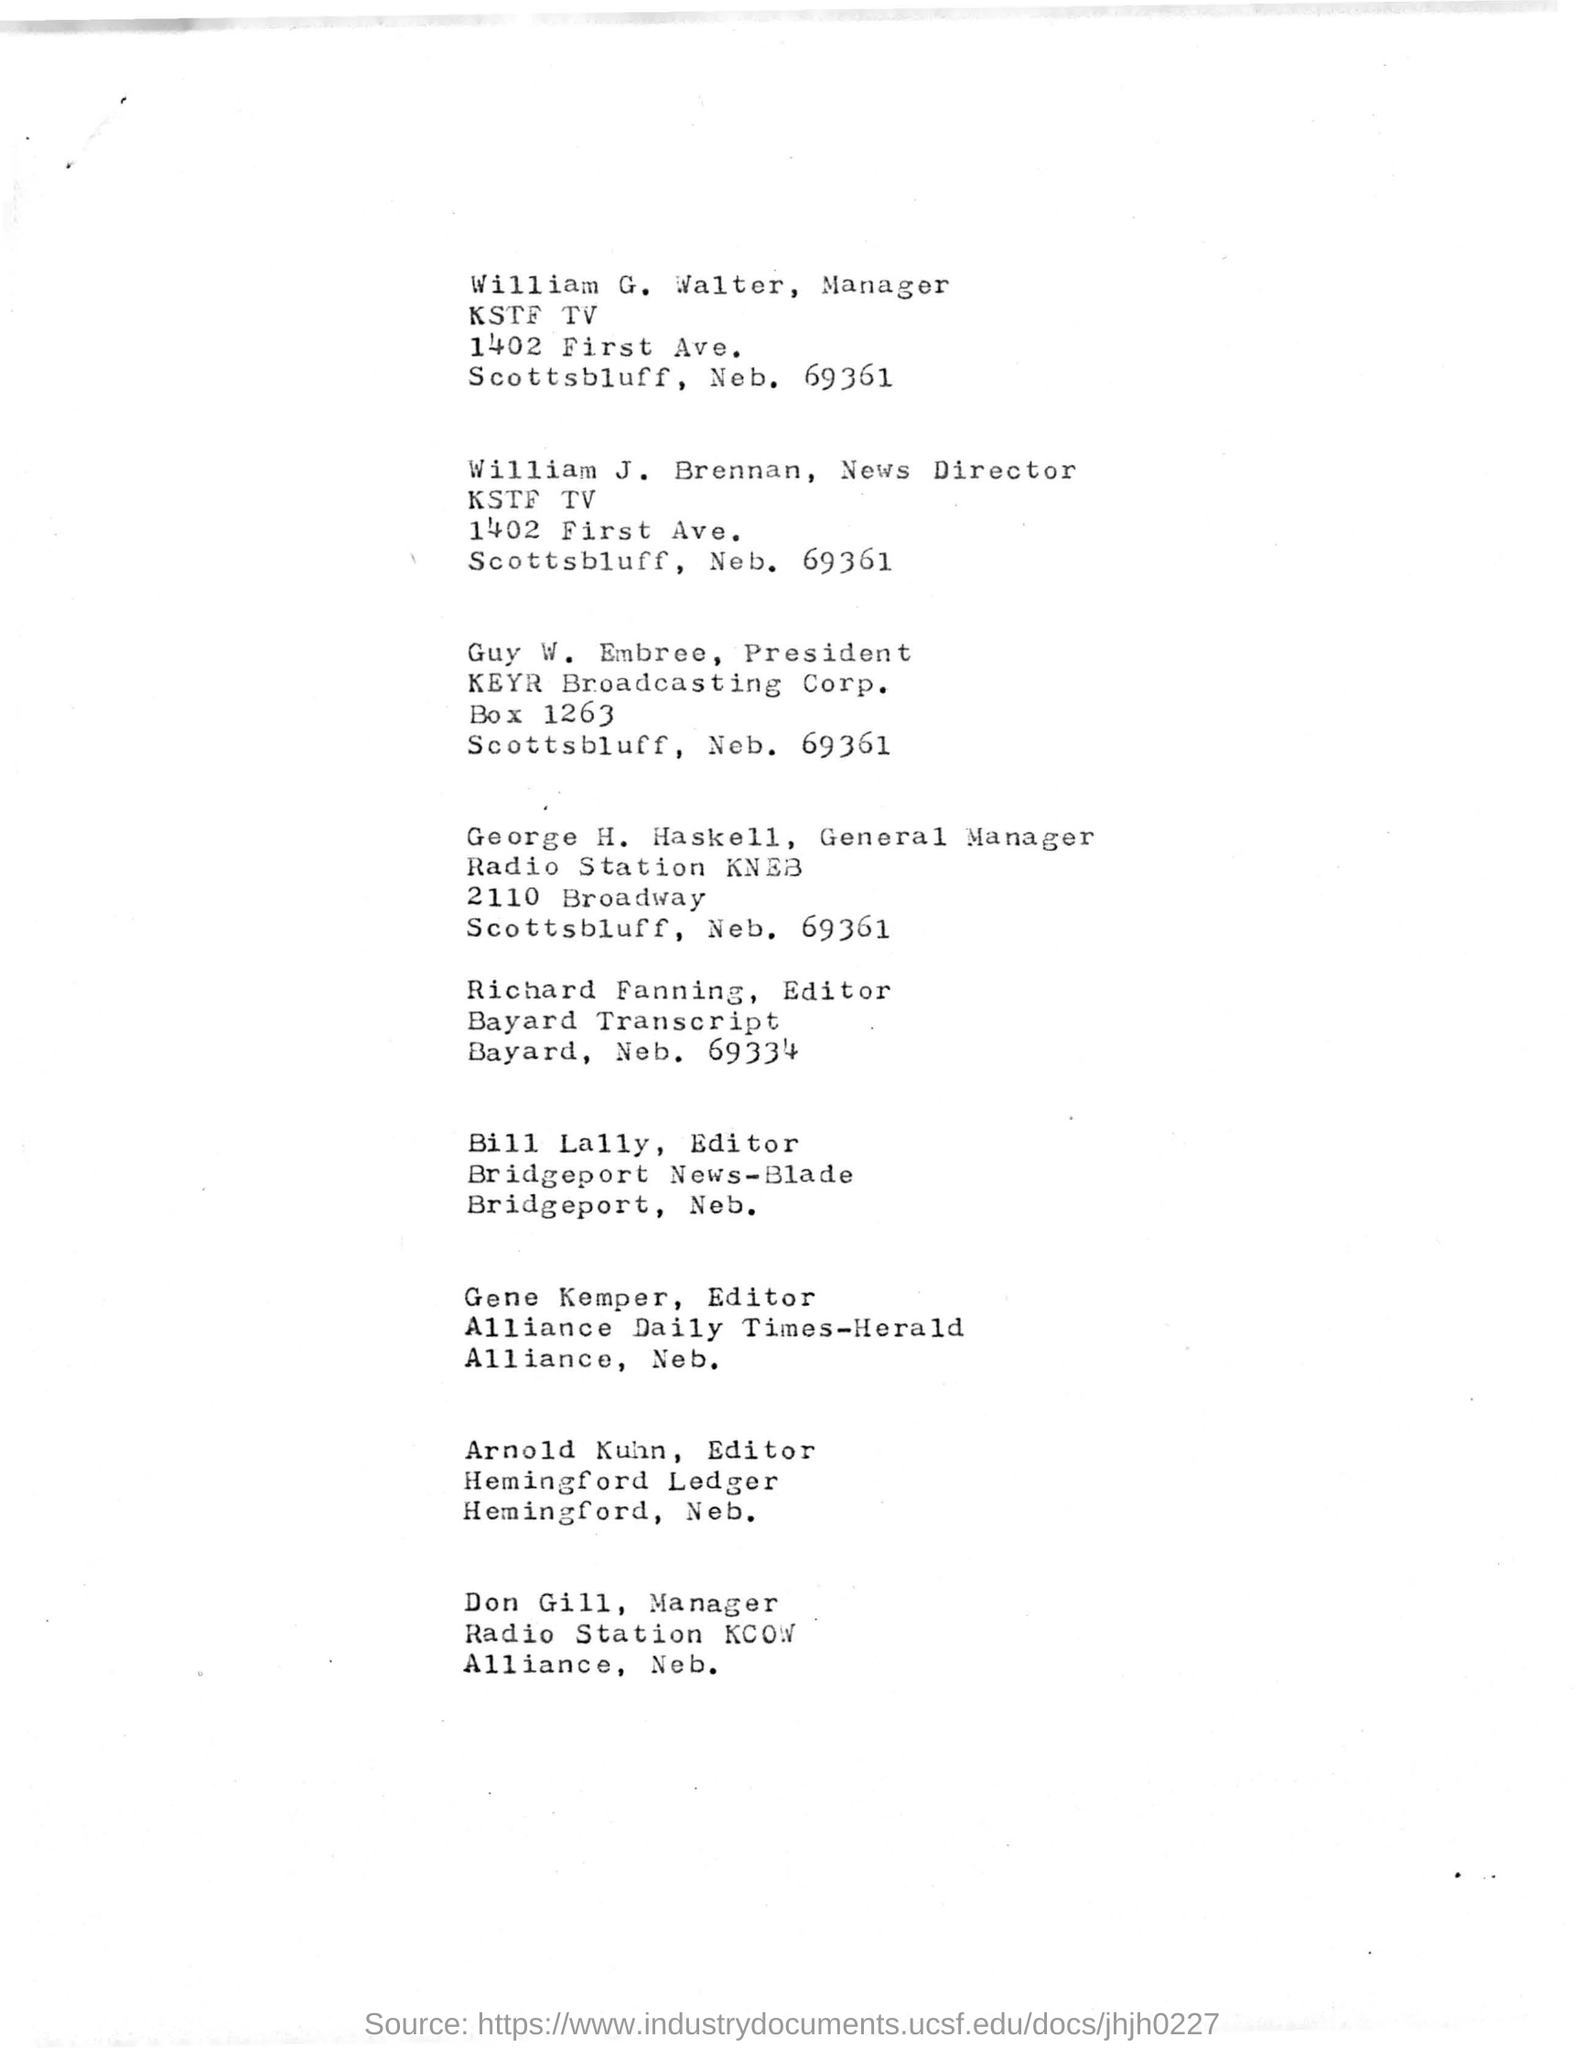Who is the manager of KSTF TV
Provide a short and direct response. William G Walter. Who is the editor of bridgeport news - blade?
Offer a very short reply. Bill Lally. 